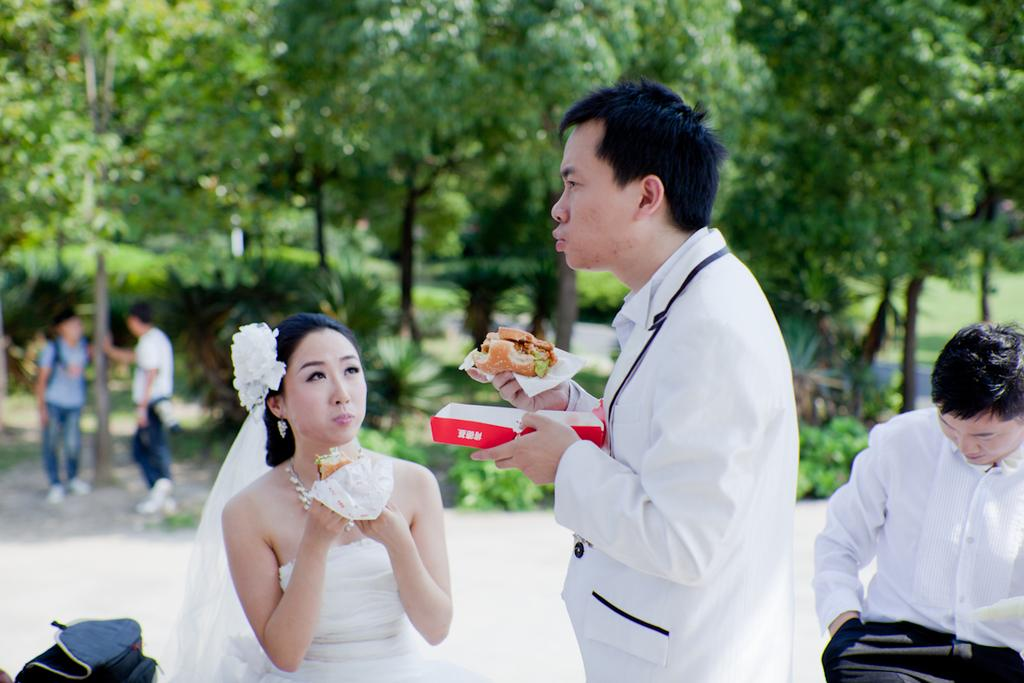How many people are in the image? There is a group of people in the image. What are some of the people doing in the image? Some people are standing on the ground, holding food with their hands, and holding bags. What can be seen in the background of the image? There are trees in the background of the image. What is the purpose of the garden in the image? There is no garden present in the image; it only features a group of people, trees in the background, and people holding food and bags. 